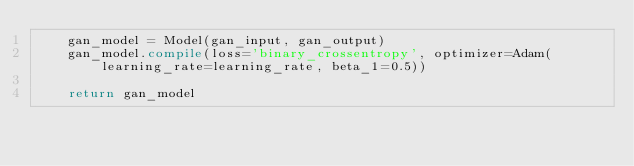<code> <loc_0><loc_0><loc_500><loc_500><_Python_>    gan_model = Model(gan_input, gan_output)
    gan_model.compile(loss='binary_crossentropy', optimizer=Adam(learning_rate=learning_rate, beta_1=0.5))

    return gan_model
</code> 